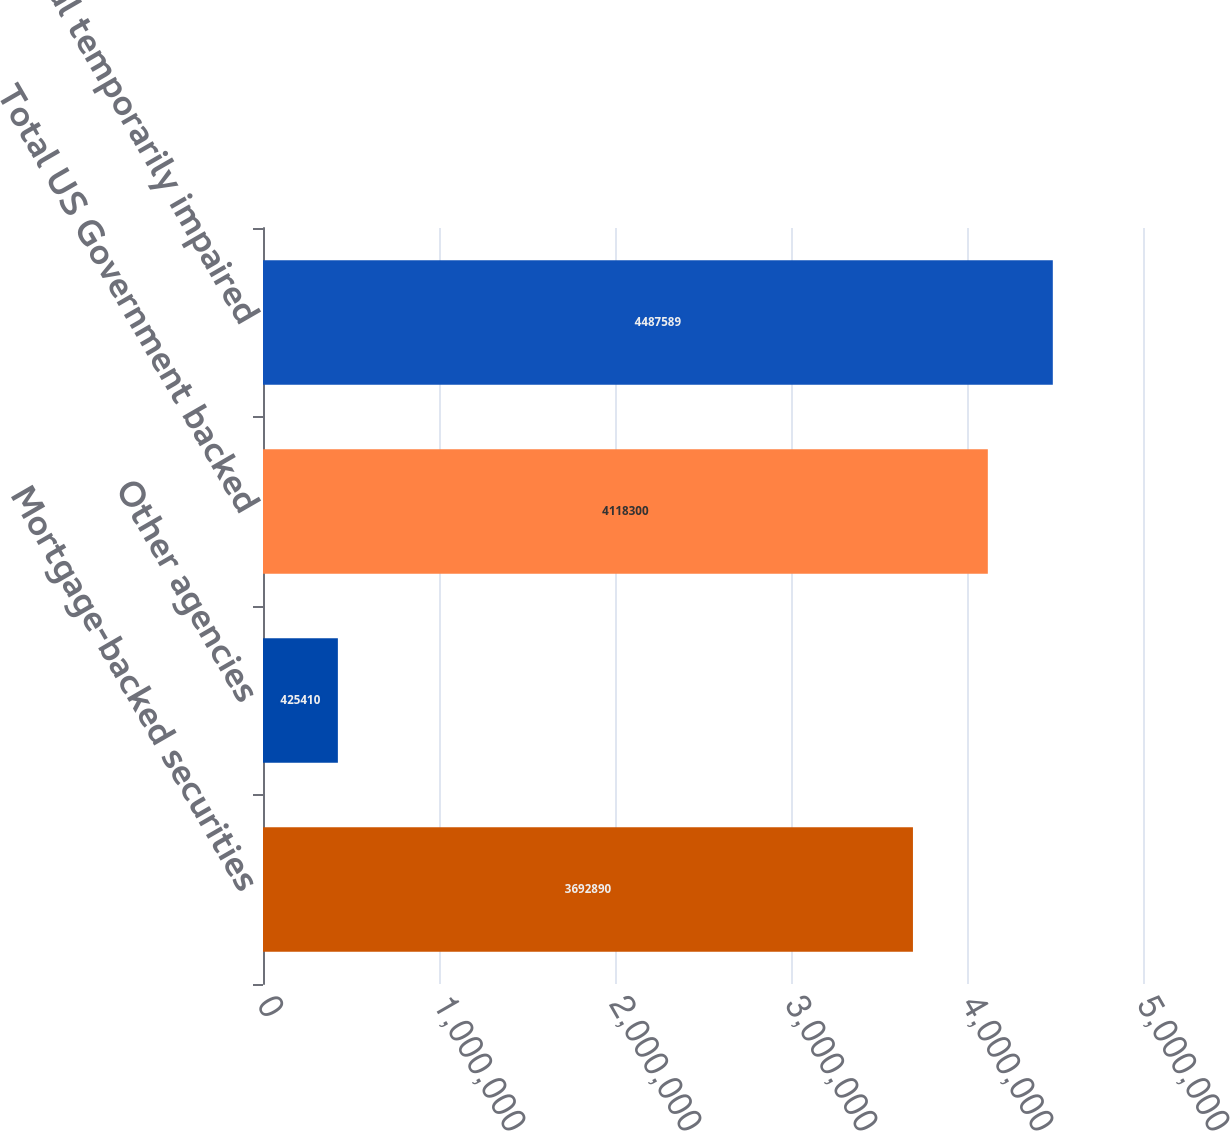Convert chart. <chart><loc_0><loc_0><loc_500><loc_500><bar_chart><fcel>Mortgage-backed securities<fcel>Other agencies<fcel>Total US Government backed<fcel>Total temporarily impaired<nl><fcel>3.69289e+06<fcel>425410<fcel>4.1183e+06<fcel>4.48759e+06<nl></chart> 